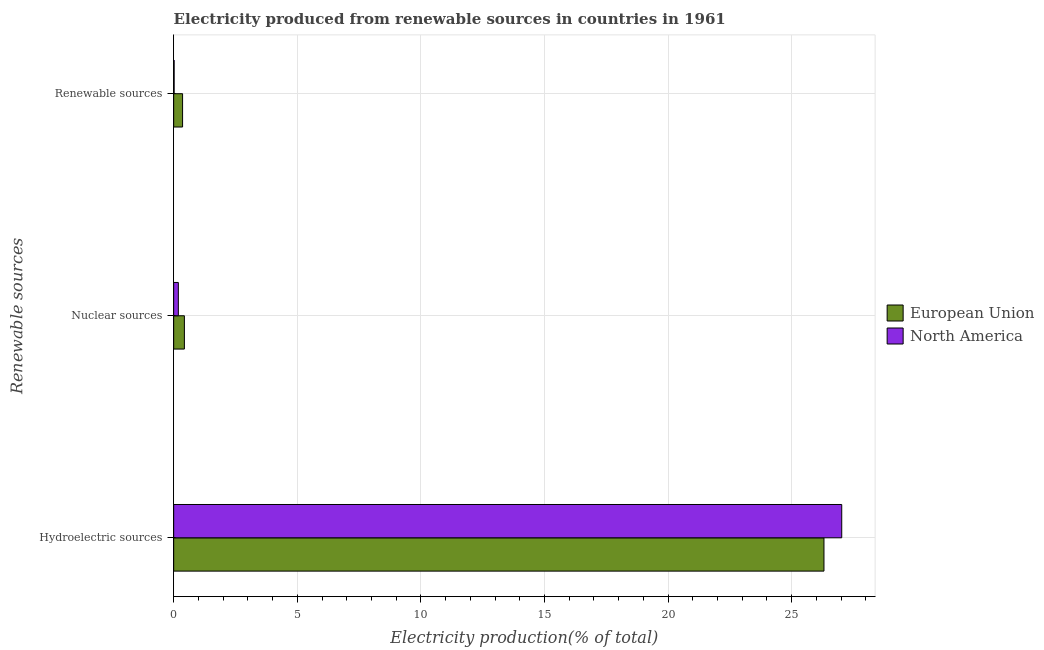How many different coloured bars are there?
Offer a very short reply. 2. Are the number of bars per tick equal to the number of legend labels?
Keep it short and to the point. Yes. Are the number of bars on each tick of the Y-axis equal?
Offer a very short reply. Yes. What is the label of the 2nd group of bars from the top?
Provide a short and direct response. Nuclear sources. What is the percentage of electricity produced by nuclear sources in North America?
Your response must be concise. 0.19. Across all countries, what is the maximum percentage of electricity produced by nuclear sources?
Your response must be concise. 0.43. Across all countries, what is the minimum percentage of electricity produced by hydroelectric sources?
Offer a very short reply. 26.31. In which country was the percentage of electricity produced by renewable sources maximum?
Ensure brevity in your answer.  European Union. In which country was the percentage of electricity produced by renewable sources minimum?
Provide a short and direct response. North America. What is the total percentage of electricity produced by nuclear sources in the graph?
Make the answer very short. 0.62. What is the difference between the percentage of electricity produced by renewable sources in European Union and that in North America?
Give a very brief answer. 0.34. What is the difference between the percentage of electricity produced by nuclear sources in European Union and the percentage of electricity produced by renewable sources in North America?
Provide a succinct answer. 0.41. What is the average percentage of electricity produced by nuclear sources per country?
Ensure brevity in your answer.  0.31. What is the difference between the percentage of electricity produced by hydroelectric sources and percentage of electricity produced by nuclear sources in North America?
Ensure brevity in your answer.  26.84. What is the ratio of the percentage of electricity produced by nuclear sources in European Union to that in North America?
Your answer should be compact. 2.29. Is the percentage of electricity produced by renewable sources in European Union less than that in North America?
Your answer should be very brief. No. Is the difference between the percentage of electricity produced by renewable sources in North America and European Union greater than the difference between the percentage of electricity produced by nuclear sources in North America and European Union?
Keep it short and to the point. No. What is the difference between the highest and the second highest percentage of electricity produced by renewable sources?
Keep it short and to the point. 0.34. What is the difference between the highest and the lowest percentage of electricity produced by hydroelectric sources?
Provide a succinct answer. 0.72. Is the sum of the percentage of electricity produced by hydroelectric sources in European Union and North America greater than the maximum percentage of electricity produced by renewable sources across all countries?
Your response must be concise. Yes. How are the legend labels stacked?
Provide a short and direct response. Vertical. What is the title of the graph?
Ensure brevity in your answer.  Electricity produced from renewable sources in countries in 1961. What is the label or title of the X-axis?
Offer a very short reply. Electricity production(% of total). What is the label or title of the Y-axis?
Ensure brevity in your answer.  Renewable sources. What is the Electricity production(% of total) in European Union in Hydroelectric sources?
Your answer should be very brief. 26.31. What is the Electricity production(% of total) in North America in Hydroelectric sources?
Give a very brief answer. 27.02. What is the Electricity production(% of total) in European Union in Nuclear sources?
Offer a terse response. 0.43. What is the Electricity production(% of total) in North America in Nuclear sources?
Your response must be concise. 0.19. What is the Electricity production(% of total) of European Union in Renewable sources?
Offer a very short reply. 0.36. What is the Electricity production(% of total) in North America in Renewable sources?
Your response must be concise. 0.02. Across all Renewable sources, what is the maximum Electricity production(% of total) in European Union?
Provide a short and direct response. 26.31. Across all Renewable sources, what is the maximum Electricity production(% of total) in North America?
Keep it short and to the point. 27.02. Across all Renewable sources, what is the minimum Electricity production(% of total) in European Union?
Provide a short and direct response. 0.36. Across all Renewable sources, what is the minimum Electricity production(% of total) of North America?
Your answer should be very brief. 0.02. What is the total Electricity production(% of total) in European Union in the graph?
Your answer should be very brief. 27.1. What is the total Electricity production(% of total) of North America in the graph?
Provide a succinct answer. 27.23. What is the difference between the Electricity production(% of total) of European Union in Hydroelectric sources and that in Nuclear sources?
Offer a very short reply. 25.87. What is the difference between the Electricity production(% of total) of North America in Hydroelectric sources and that in Nuclear sources?
Your answer should be very brief. 26.84. What is the difference between the Electricity production(% of total) in European Union in Hydroelectric sources and that in Renewable sources?
Provide a short and direct response. 25.95. What is the difference between the Electricity production(% of total) of North America in Hydroelectric sources and that in Renewable sources?
Give a very brief answer. 27.01. What is the difference between the Electricity production(% of total) of European Union in Nuclear sources and that in Renewable sources?
Your response must be concise. 0.07. What is the difference between the Electricity production(% of total) in North America in Nuclear sources and that in Renewable sources?
Ensure brevity in your answer.  0.17. What is the difference between the Electricity production(% of total) of European Union in Hydroelectric sources and the Electricity production(% of total) of North America in Nuclear sources?
Offer a very short reply. 26.12. What is the difference between the Electricity production(% of total) in European Union in Hydroelectric sources and the Electricity production(% of total) in North America in Renewable sources?
Provide a succinct answer. 26.29. What is the difference between the Electricity production(% of total) in European Union in Nuclear sources and the Electricity production(% of total) in North America in Renewable sources?
Your answer should be very brief. 0.41. What is the average Electricity production(% of total) of European Union per Renewable sources?
Give a very brief answer. 9.03. What is the average Electricity production(% of total) of North America per Renewable sources?
Your answer should be very brief. 9.08. What is the difference between the Electricity production(% of total) of European Union and Electricity production(% of total) of North America in Hydroelectric sources?
Your response must be concise. -0.72. What is the difference between the Electricity production(% of total) of European Union and Electricity production(% of total) of North America in Nuclear sources?
Ensure brevity in your answer.  0.24. What is the difference between the Electricity production(% of total) in European Union and Electricity production(% of total) in North America in Renewable sources?
Provide a short and direct response. 0.34. What is the ratio of the Electricity production(% of total) of European Union in Hydroelectric sources to that in Nuclear sources?
Ensure brevity in your answer.  60.68. What is the ratio of the Electricity production(% of total) in North America in Hydroelectric sources to that in Nuclear sources?
Offer a terse response. 142.88. What is the ratio of the Electricity production(% of total) of European Union in Hydroelectric sources to that in Renewable sources?
Give a very brief answer. 73.09. What is the ratio of the Electricity production(% of total) in North America in Hydroelectric sources to that in Renewable sources?
Your response must be concise. 1427.27. What is the ratio of the Electricity production(% of total) of European Union in Nuclear sources to that in Renewable sources?
Provide a short and direct response. 1.2. What is the ratio of the Electricity production(% of total) of North America in Nuclear sources to that in Renewable sources?
Offer a very short reply. 9.99. What is the difference between the highest and the second highest Electricity production(% of total) of European Union?
Your response must be concise. 25.87. What is the difference between the highest and the second highest Electricity production(% of total) in North America?
Provide a succinct answer. 26.84. What is the difference between the highest and the lowest Electricity production(% of total) of European Union?
Make the answer very short. 25.95. What is the difference between the highest and the lowest Electricity production(% of total) in North America?
Keep it short and to the point. 27.01. 